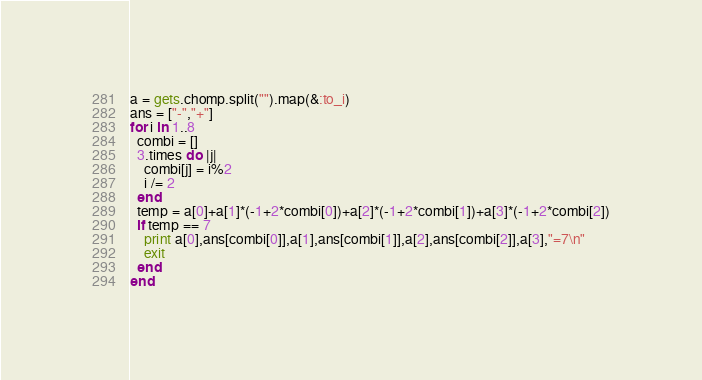Convert code to text. <code><loc_0><loc_0><loc_500><loc_500><_Ruby_>a = gets.chomp.split("").map(&:to_i)
ans = ["-","+"]
for i in 1..8
  combi = []
  3.times do |j|
    combi[j] = i%2
    i /= 2
  end
  temp = a[0]+a[1]*(-1+2*combi[0])+a[2]*(-1+2*combi[1])+a[3]*(-1+2*combi[2])
  if temp == 7
    print a[0],ans[combi[0]],a[1],ans[combi[1]],a[2],ans[combi[2]],a[3],"=7\n"
    exit
  end
end</code> 